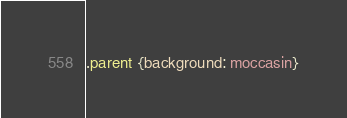Convert code to text. <code><loc_0><loc_0><loc_500><loc_500><_CSS_>.parent {background: moccasin}
</code> 